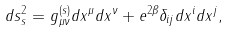Convert formula to latex. <formula><loc_0><loc_0><loc_500><loc_500>d s ^ { 2 } _ { s } = g ^ { ( s ) } _ { \mu \nu } d x ^ { \mu } d x ^ { \nu } + e ^ { 2 \beta } \delta _ { i j } d x ^ { i } d x ^ { j } ,</formula> 